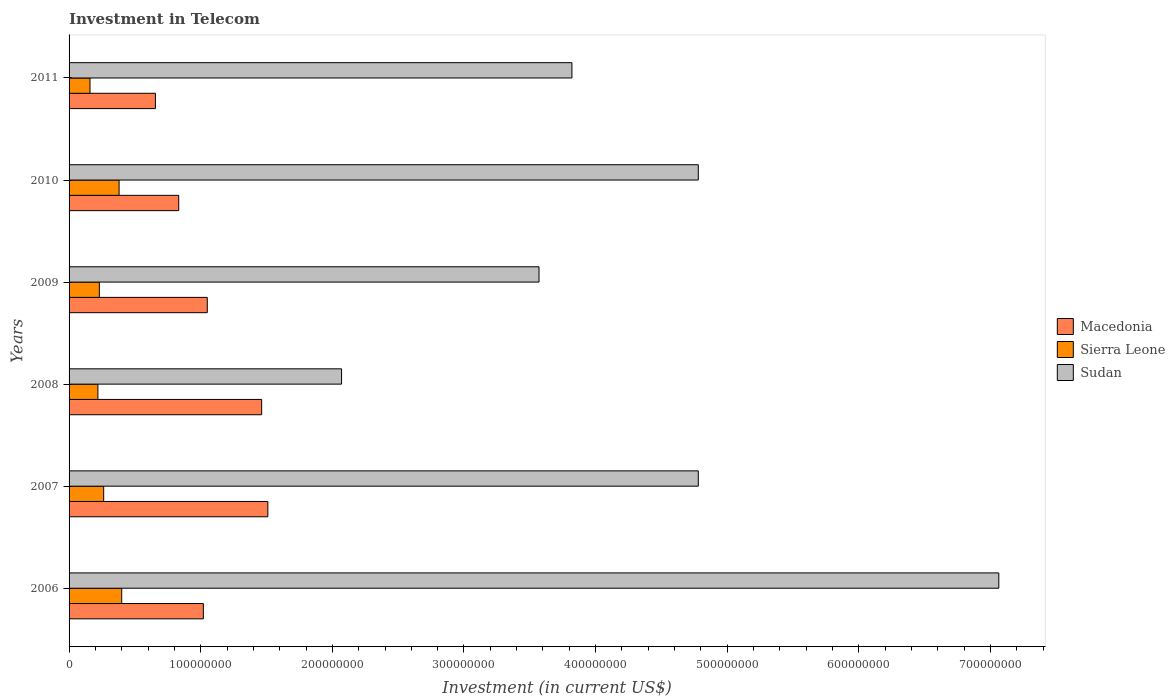How many different coloured bars are there?
Make the answer very short. 3. How many groups of bars are there?
Offer a very short reply. 6. How many bars are there on the 6th tick from the top?
Give a very brief answer. 3. What is the label of the 2nd group of bars from the top?
Provide a succinct answer. 2010. In how many cases, is the number of bars for a given year not equal to the number of legend labels?
Offer a terse response. 0. What is the amount invested in telecom in Sudan in 2009?
Keep it short and to the point. 3.57e+08. Across all years, what is the maximum amount invested in telecom in Sudan?
Make the answer very short. 7.06e+08. Across all years, what is the minimum amount invested in telecom in Macedonia?
Your response must be concise. 6.56e+07. What is the total amount invested in telecom in Macedonia in the graph?
Your answer should be compact. 6.53e+08. What is the difference between the amount invested in telecom in Sierra Leone in 2008 and that in 2010?
Offer a very short reply. -1.61e+07. What is the difference between the amount invested in telecom in Sierra Leone in 2010 and the amount invested in telecom in Sudan in 2011?
Keep it short and to the point. -3.44e+08. What is the average amount invested in telecom in Macedonia per year?
Your answer should be very brief. 1.09e+08. In the year 2008, what is the difference between the amount invested in telecom in Sierra Leone and amount invested in telecom in Sudan?
Make the answer very short. -1.85e+08. What is the ratio of the amount invested in telecom in Sierra Leone in 2007 to that in 2011?
Provide a succinct answer. 1.65. Is the amount invested in telecom in Sierra Leone in 2006 less than that in 2010?
Provide a short and direct response. No. Is the difference between the amount invested in telecom in Sierra Leone in 2009 and 2010 greater than the difference between the amount invested in telecom in Sudan in 2009 and 2010?
Offer a terse response. Yes. What is the difference between the highest and the lowest amount invested in telecom in Macedonia?
Keep it short and to the point. 8.54e+07. In how many years, is the amount invested in telecom in Sierra Leone greater than the average amount invested in telecom in Sierra Leone taken over all years?
Give a very brief answer. 2. Is the sum of the amount invested in telecom in Sudan in 2008 and 2010 greater than the maximum amount invested in telecom in Sierra Leone across all years?
Provide a short and direct response. Yes. What does the 2nd bar from the top in 2007 represents?
Provide a succinct answer. Sierra Leone. What does the 3rd bar from the bottom in 2007 represents?
Your answer should be very brief. Sudan. Is it the case that in every year, the sum of the amount invested in telecom in Sierra Leone and amount invested in telecom in Sudan is greater than the amount invested in telecom in Macedonia?
Your response must be concise. Yes. Are all the bars in the graph horizontal?
Your answer should be very brief. Yes. Does the graph contain grids?
Your answer should be compact. No. Where does the legend appear in the graph?
Offer a very short reply. Center right. What is the title of the graph?
Offer a very short reply. Investment in Telecom. Does "United States" appear as one of the legend labels in the graph?
Provide a short and direct response. No. What is the label or title of the X-axis?
Provide a short and direct response. Investment (in current US$). What is the label or title of the Y-axis?
Keep it short and to the point. Years. What is the Investment (in current US$) in Macedonia in 2006?
Your response must be concise. 1.02e+08. What is the Investment (in current US$) in Sierra Leone in 2006?
Make the answer very short. 4.00e+07. What is the Investment (in current US$) in Sudan in 2006?
Provide a succinct answer. 7.06e+08. What is the Investment (in current US$) of Macedonia in 2007?
Offer a terse response. 1.51e+08. What is the Investment (in current US$) in Sierra Leone in 2007?
Provide a succinct answer. 2.63e+07. What is the Investment (in current US$) of Sudan in 2007?
Give a very brief answer. 4.78e+08. What is the Investment (in current US$) of Macedonia in 2008?
Your answer should be very brief. 1.46e+08. What is the Investment (in current US$) of Sierra Leone in 2008?
Make the answer very short. 2.19e+07. What is the Investment (in current US$) in Sudan in 2008?
Give a very brief answer. 2.07e+08. What is the Investment (in current US$) of Macedonia in 2009?
Provide a succinct answer. 1.05e+08. What is the Investment (in current US$) of Sierra Leone in 2009?
Offer a very short reply. 2.30e+07. What is the Investment (in current US$) of Sudan in 2009?
Ensure brevity in your answer.  3.57e+08. What is the Investment (in current US$) in Macedonia in 2010?
Give a very brief answer. 8.33e+07. What is the Investment (in current US$) in Sierra Leone in 2010?
Give a very brief answer. 3.80e+07. What is the Investment (in current US$) of Sudan in 2010?
Provide a succinct answer. 4.78e+08. What is the Investment (in current US$) in Macedonia in 2011?
Make the answer very short. 6.56e+07. What is the Investment (in current US$) of Sierra Leone in 2011?
Give a very brief answer. 1.59e+07. What is the Investment (in current US$) of Sudan in 2011?
Give a very brief answer. 3.82e+08. Across all years, what is the maximum Investment (in current US$) in Macedonia?
Offer a very short reply. 1.51e+08. Across all years, what is the maximum Investment (in current US$) of Sierra Leone?
Ensure brevity in your answer.  4.00e+07. Across all years, what is the maximum Investment (in current US$) of Sudan?
Give a very brief answer. 7.06e+08. Across all years, what is the minimum Investment (in current US$) of Macedonia?
Keep it short and to the point. 6.56e+07. Across all years, what is the minimum Investment (in current US$) of Sierra Leone?
Give a very brief answer. 1.59e+07. Across all years, what is the minimum Investment (in current US$) in Sudan?
Make the answer very short. 2.07e+08. What is the total Investment (in current US$) of Macedonia in the graph?
Make the answer very short. 6.53e+08. What is the total Investment (in current US$) of Sierra Leone in the graph?
Give a very brief answer. 1.65e+08. What is the total Investment (in current US$) of Sudan in the graph?
Offer a very short reply. 2.61e+09. What is the difference between the Investment (in current US$) of Macedonia in 2006 and that in 2007?
Your answer should be very brief. -4.90e+07. What is the difference between the Investment (in current US$) in Sierra Leone in 2006 and that in 2007?
Provide a short and direct response. 1.37e+07. What is the difference between the Investment (in current US$) of Sudan in 2006 and that in 2007?
Give a very brief answer. 2.28e+08. What is the difference between the Investment (in current US$) of Macedonia in 2006 and that in 2008?
Make the answer very short. -4.43e+07. What is the difference between the Investment (in current US$) of Sierra Leone in 2006 and that in 2008?
Your answer should be very brief. 1.81e+07. What is the difference between the Investment (in current US$) of Sudan in 2006 and that in 2008?
Provide a short and direct response. 4.99e+08. What is the difference between the Investment (in current US$) in Macedonia in 2006 and that in 2009?
Give a very brief answer. -3.00e+06. What is the difference between the Investment (in current US$) of Sierra Leone in 2006 and that in 2009?
Provide a succinct answer. 1.70e+07. What is the difference between the Investment (in current US$) in Sudan in 2006 and that in 2009?
Offer a terse response. 3.49e+08. What is the difference between the Investment (in current US$) of Macedonia in 2006 and that in 2010?
Keep it short and to the point. 1.87e+07. What is the difference between the Investment (in current US$) of Sudan in 2006 and that in 2010?
Ensure brevity in your answer.  2.28e+08. What is the difference between the Investment (in current US$) in Macedonia in 2006 and that in 2011?
Offer a very short reply. 3.64e+07. What is the difference between the Investment (in current US$) in Sierra Leone in 2006 and that in 2011?
Provide a succinct answer. 2.41e+07. What is the difference between the Investment (in current US$) of Sudan in 2006 and that in 2011?
Your answer should be very brief. 3.24e+08. What is the difference between the Investment (in current US$) of Macedonia in 2007 and that in 2008?
Provide a short and direct response. 4.70e+06. What is the difference between the Investment (in current US$) in Sierra Leone in 2007 and that in 2008?
Provide a succinct answer. 4.40e+06. What is the difference between the Investment (in current US$) in Sudan in 2007 and that in 2008?
Ensure brevity in your answer.  2.71e+08. What is the difference between the Investment (in current US$) of Macedonia in 2007 and that in 2009?
Offer a terse response. 4.60e+07. What is the difference between the Investment (in current US$) of Sierra Leone in 2007 and that in 2009?
Offer a terse response. 3.30e+06. What is the difference between the Investment (in current US$) of Sudan in 2007 and that in 2009?
Your answer should be compact. 1.21e+08. What is the difference between the Investment (in current US$) in Macedonia in 2007 and that in 2010?
Keep it short and to the point. 6.77e+07. What is the difference between the Investment (in current US$) of Sierra Leone in 2007 and that in 2010?
Provide a succinct answer. -1.17e+07. What is the difference between the Investment (in current US$) in Sudan in 2007 and that in 2010?
Ensure brevity in your answer.  0. What is the difference between the Investment (in current US$) of Macedonia in 2007 and that in 2011?
Your answer should be very brief. 8.54e+07. What is the difference between the Investment (in current US$) in Sierra Leone in 2007 and that in 2011?
Your answer should be very brief. 1.04e+07. What is the difference between the Investment (in current US$) of Sudan in 2007 and that in 2011?
Ensure brevity in your answer.  9.60e+07. What is the difference between the Investment (in current US$) of Macedonia in 2008 and that in 2009?
Provide a short and direct response. 4.13e+07. What is the difference between the Investment (in current US$) of Sierra Leone in 2008 and that in 2009?
Provide a succinct answer. -1.10e+06. What is the difference between the Investment (in current US$) in Sudan in 2008 and that in 2009?
Your answer should be very brief. -1.50e+08. What is the difference between the Investment (in current US$) of Macedonia in 2008 and that in 2010?
Give a very brief answer. 6.30e+07. What is the difference between the Investment (in current US$) in Sierra Leone in 2008 and that in 2010?
Ensure brevity in your answer.  -1.61e+07. What is the difference between the Investment (in current US$) of Sudan in 2008 and that in 2010?
Make the answer very short. -2.71e+08. What is the difference between the Investment (in current US$) of Macedonia in 2008 and that in 2011?
Your response must be concise. 8.07e+07. What is the difference between the Investment (in current US$) of Sierra Leone in 2008 and that in 2011?
Ensure brevity in your answer.  6.00e+06. What is the difference between the Investment (in current US$) in Sudan in 2008 and that in 2011?
Offer a very short reply. -1.75e+08. What is the difference between the Investment (in current US$) of Macedonia in 2009 and that in 2010?
Keep it short and to the point. 2.17e+07. What is the difference between the Investment (in current US$) in Sierra Leone in 2009 and that in 2010?
Offer a terse response. -1.50e+07. What is the difference between the Investment (in current US$) of Sudan in 2009 and that in 2010?
Ensure brevity in your answer.  -1.21e+08. What is the difference between the Investment (in current US$) in Macedonia in 2009 and that in 2011?
Give a very brief answer. 3.94e+07. What is the difference between the Investment (in current US$) of Sierra Leone in 2009 and that in 2011?
Make the answer very short. 7.10e+06. What is the difference between the Investment (in current US$) of Sudan in 2009 and that in 2011?
Offer a terse response. -2.50e+07. What is the difference between the Investment (in current US$) of Macedonia in 2010 and that in 2011?
Your answer should be compact. 1.77e+07. What is the difference between the Investment (in current US$) of Sierra Leone in 2010 and that in 2011?
Your answer should be very brief. 2.21e+07. What is the difference between the Investment (in current US$) of Sudan in 2010 and that in 2011?
Keep it short and to the point. 9.60e+07. What is the difference between the Investment (in current US$) of Macedonia in 2006 and the Investment (in current US$) of Sierra Leone in 2007?
Keep it short and to the point. 7.57e+07. What is the difference between the Investment (in current US$) in Macedonia in 2006 and the Investment (in current US$) in Sudan in 2007?
Your answer should be compact. -3.76e+08. What is the difference between the Investment (in current US$) of Sierra Leone in 2006 and the Investment (in current US$) of Sudan in 2007?
Offer a terse response. -4.38e+08. What is the difference between the Investment (in current US$) in Macedonia in 2006 and the Investment (in current US$) in Sierra Leone in 2008?
Give a very brief answer. 8.01e+07. What is the difference between the Investment (in current US$) of Macedonia in 2006 and the Investment (in current US$) of Sudan in 2008?
Your response must be concise. -1.05e+08. What is the difference between the Investment (in current US$) in Sierra Leone in 2006 and the Investment (in current US$) in Sudan in 2008?
Make the answer very short. -1.67e+08. What is the difference between the Investment (in current US$) in Macedonia in 2006 and the Investment (in current US$) in Sierra Leone in 2009?
Provide a short and direct response. 7.90e+07. What is the difference between the Investment (in current US$) in Macedonia in 2006 and the Investment (in current US$) in Sudan in 2009?
Your response must be concise. -2.55e+08. What is the difference between the Investment (in current US$) of Sierra Leone in 2006 and the Investment (in current US$) of Sudan in 2009?
Ensure brevity in your answer.  -3.17e+08. What is the difference between the Investment (in current US$) of Macedonia in 2006 and the Investment (in current US$) of Sierra Leone in 2010?
Make the answer very short. 6.40e+07. What is the difference between the Investment (in current US$) in Macedonia in 2006 and the Investment (in current US$) in Sudan in 2010?
Keep it short and to the point. -3.76e+08. What is the difference between the Investment (in current US$) of Sierra Leone in 2006 and the Investment (in current US$) of Sudan in 2010?
Give a very brief answer. -4.38e+08. What is the difference between the Investment (in current US$) of Macedonia in 2006 and the Investment (in current US$) of Sierra Leone in 2011?
Keep it short and to the point. 8.61e+07. What is the difference between the Investment (in current US$) in Macedonia in 2006 and the Investment (in current US$) in Sudan in 2011?
Your answer should be compact. -2.80e+08. What is the difference between the Investment (in current US$) of Sierra Leone in 2006 and the Investment (in current US$) of Sudan in 2011?
Provide a short and direct response. -3.42e+08. What is the difference between the Investment (in current US$) of Macedonia in 2007 and the Investment (in current US$) of Sierra Leone in 2008?
Your answer should be compact. 1.29e+08. What is the difference between the Investment (in current US$) of Macedonia in 2007 and the Investment (in current US$) of Sudan in 2008?
Make the answer very short. -5.60e+07. What is the difference between the Investment (in current US$) in Sierra Leone in 2007 and the Investment (in current US$) in Sudan in 2008?
Provide a succinct answer. -1.81e+08. What is the difference between the Investment (in current US$) in Macedonia in 2007 and the Investment (in current US$) in Sierra Leone in 2009?
Your answer should be very brief. 1.28e+08. What is the difference between the Investment (in current US$) in Macedonia in 2007 and the Investment (in current US$) in Sudan in 2009?
Give a very brief answer. -2.06e+08. What is the difference between the Investment (in current US$) of Sierra Leone in 2007 and the Investment (in current US$) of Sudan in 2009?
Your response must be concise. -3.31e+08. What is the difference between the Investment (in current US$) of Macedonia in 2007 and the Investment (in current US$) of Sierra Leone in 2010?
Offer a terse response. 1.13e+08. What is the difference between the Investment (in current US$) in Macedonia in 2007 and the Investment (in current US$) in Sudan in 2010?
Ensure brevity in your answer.  -3.27e+08. What is the difference between the Investment (in current US$) in Sierra Leone in 2007 and the Investment (in current US$) in Sudan in 2010?
Ensure brevity in your answer.  -4.52e+08. What is the difference between the Investment (in current US$) in Macedonia in 2007 and the Investment (in current US$) in Sierra Leone in 2011?
Your response must be concise. 1.35e+08. What is the difference between the Investment (in current US$) in Macedonia in 2007 and the Investment (in current US$) in Sudan in 2011?
Offer a terse response. -2.31e+08. What is the difference between the Investment (in current US$) of Sierra Leone in 2007 and the Investment (in current US$) of Sudan in 2011?
Your answer should be compact. -3.56e+08. What is the difference between the Investment (in current US$) of Macedonia in 2008 and the Investment (in current US$) of Sierra Leone in 2009?
Offer a terse response. 1.23e+08. What is the difference between the Investment (in current US$) in Macedonia in 2008 and the Investment (in current US$) in Sudan in 2009?
Your answer should be very brief. -2.11e+08. What is the difference between the Investment (in current US$) of Sierra Leone in 2008 and the Investment (in current US$) of Sudan in 2009?
Provide a short and direct response. -3.35e+08. What is the difference between the Investment (in current US$) of Macedonia in 2008 and the Investment (in current US$) of Sierra Leone in 2010?
Ensure brevity in your answer.  1.08e+08. What is the difference between the Investment (in current US$) in Macedonia in 2008 and the Investment (in current US$) in Sudan in 2010?
Offer a terse response. -3.32e+08. What is the difference between the Investment (in current US$) of Sierra Leone in 2008 and the Investment (in current US$) of Sudan in 2010?
Make the answer very short. -4.56e+08. What is the difference between the Investment (in current US$) of Macedonia in 2008 and the Investment (in current US$) of Sierra Leone in 2011?
Your answer should be compact. 1.30e+08. What is the difference between the Investment (in current US$) of Macedonia in 2008 and the Investment (in current US$) of Sudan in 2011?
Keep it short and to the point. -2.36e+08. What is the difference between the Investment (in current US$) in Sierra Leone in 2008 and the Investment (in current US$) in Sudan in 2011?
Keep it short and to the point. -3.60e+08. What is the difference between the Investment (in current US$) of Macedonia in 2009 and the Investment (in current US$) of Sierra Leone in 2010?
Offer a terse response. 6.70e+07. What is the difference between the Investment (in current US$) in Macedonia in 2009 and the Investment (in current US$) in Sudan in 2010?
Provide a succinct answer. -3.73e+08. What is the difference between the Investment (in current US$) in Sierra Leone in 2009 and the Investment (in current US$) in Sudan in 2010?
Offer a very short reply. -4.55e+08. What is the difference between the Investment (in current US$) of Macedonia in 2009 and the Investment (in current US$) of Sierra Leone in 2011?
Provide a short and direct response. 8.91e+07. What is the difference between the Investment (in current US$) in Macedonia in 2009 and the Investment (in current US$) in Sudan in 2011?
Offer a terse response. -2.77e+08. What is the difference between the Investment (in current US$) of Sierra Leone in 2009 and the Investment (in current US$) of Sudan in 2011?
Make the answer very short. -3.59e+08. What is the difference between the Investment (in current US$) in Macedonia in 2010 and the Investment (in current US$) in Sierra Leone in 2011?
Offer a very short reply. 6.74e+07. What is the difference between the Investment (in current US$) of Macedonia in 2010 and the Investment (in current US$) of Sudan in 2011?
Your answer should be compact. -2.99e+08. What is the difference between the Investment (in current US$) in Sierra Leone in 2010 and the Investment (in current US$) in Sudan in 2011?
Your answer should be very brief. -3.44e+08. What is the average Investment (in current US$) in Macedonia per year?
Ensure brevity in your answer.  1.09e+08. What is the average Investment (in current US$) of Sierra Leone per year?
Make the answer very short. 2.75e+07. What is the average Investment (in current US$) of Sudan per year?
Offer a very short reply. 4.35e+08. In the year 2006, what is the difference between the Investment (in current US$) in Macedonia and Investment (in current US$) in Sierra Leone?
Your answer should be very brief. 6.20e+07. In the year 2006, what is the difference between the Investment (in current US$) of Macedonia and Investment (in current US$) of Sudan?
Your answer should be very brief. -6.04e+08. In the year 2006, what is the difference between the Investment (in current US$) in Sierra Leone and Investment (in current US$) in Sudan?
Your answer should be very brief. -6.66e+08. In the year 2007, what is the difference between the Investment (in current US$) of Macedonia and Investment (in current US$) of Sierra Leone?
Your answer should be compact. 1.25e+08. In the year 2007, what is the difference between the Investment (in current US$) of Macedonia and Investment (in current US$) of Sudan?
Give a very brief answer. -3.27e+08. In the year 2007, what is the difference between the Investment (in current US$) of Sierra Leone and Investment (in current US$) of Sudan?
Give a very brief answer. -4.52e+08. In the year 2008, what is the difference between the Investment (in current US$) of Macedonia and Investment (in current US$) of Sierra Leone?
Your answer should be very brief. 1.24e+08. In the year 2008, what is the difference between the Investment (in current US$) of Macedonia and Investment (in current US$) of Sudan?
Offer a terse response. -6.07e+07. In the year 2008, what is the difference between the Investment (in current US$) of Sierra Leone and Investment (in current US$) of Sudan?
Offer a terse response. -1.85e+08. In the year 2009, what is the difference between the Investment (in current US$) of Macedonia and Investment (in current US$) of Sierra Leone?
Make the answer very short. 8.20e+07. In the year 2009, what is the difference between the Investment (in current US$) in Macedonia and Investment (in current US$) in Sudan?
Keep it short and to the point. -2.52e+08. In the year 2009, what is the difference between the Investment (in current US$) in Sierra Leone and Investment (in current US$) in Sudan?
Provide a succinct answer. -3.34e+08. In the year 2010, what is the difference between the Investment (in current US$) in Macedonia and Investment (in current US$) in Sierra Leone?
Provide a short and direct response. 4.53e+07. In the year 2010, what is the difference between the Investment (in current US$) in Macedonia and Investment (in current US$) in Sudan?
Offer a terse response. -3.95e+08. In the year 2010, what is the difference between the Investment (in current US$) in Sierra Leone and Investment (in current US$) in Sudan?
Your response must be concise. -4.40e+08. In the year 2011, what is the difference between the Investment (in current US$) in Macedonia and Investment (in current US$) in Sierra Leone?
Your answer should be very brief. 4.97e+07. In the year 2011, what is the difference between the Investment (in current US$) of Macedonia and Investment (in current US$) of Sudan?
Your answer should be very brief. -3.16e+08. In the year 2011, what is the difference between the Investment (in current US$) of Sierra Leone and Investment (in current US$) of Sudan?
Ensure brevity in your answer.  -3.66e+08. What is the ratio of the Investment (in current US$) of Macedonia in 2006 to that in 2007?
Keep it short and to the point. 0.68. What is the ratio of the Investment (in current US$) in Sierra Leone in 2006 to that in 2007?
Your response must be concise. 1.52. What is the ratio of the Investment (in current US$) of Sudan in 2006 to that in 2007?
Provide a short and direct response. 1.48. What is the ratio of the Investment (in current US$) in Macedonia in 2006 to that in 2008?
Provide a short and direct response. 0.7. What is the ratio of the Investment (in current US$) in Sierra Leone in 2006 to that in 2008?
Give a very brief answer. 1.83. What is the ratio of the Investment (in current US$) in Sudan in 2006 to that in 2008?
Provide a succinct answer. 3.41. What is the ratio of the Investment (in current US$) of Macedonia in 2006 to that in 2009?
Provide a succinct answer. 0.97. What is the ratio of the Investment (in current US$) in Sierra Leone in 2006 to that in 2009?
Your answer should be very brief. 1.74. What is the ratio of the Investment (in current US$) in Sudan in 2006 to that in 2009?
Ensure brevity in your answer.  1.98. What is the ratio of the Investment (in current US$) in Macedonia in 2006 to that in 2010?
Give a very brief answer. 1.22. What is the ratio of the Investment (in current US$) in Sierra Leone in 2006 to that in 2010?
Keep it short and to the point. 1.05. What is the ratio of the Investment (in current US$) in Sudan in 2006 to that in 2010?
Keep it short and to the point. 1.48. What is the ratio of the Investment (in current US$) in Macedonia in 2006 to that in 2011?
Offer a terse response. 1.55. What is the ratio of the Investment (in current US$) of Sierra Leone in 2006 to that in 2011?
Your answer should be compact. 2.52. What is the ratio of the Investment (in current US$) in Sudan in 2006 to that in 2011?
Offer a terse response. 1.85. What is the ratio of the Investment (in current US$) in Macedonia in 2007 to that in 2008?
Make the answer very short. 1.03. What is the ratio of the Investment (in current US$) in Sierra Leone in 2007 to that in 2008?
Ensure brevity in your answer.  1.2. What is the ratio of the Investment (in current US$) of Sudan in 2007 to that in 2008?
Your response must be concise. 2.31. What is the ratio of the Investment (in current US$) in Macedonia in 2007 to that in 2009?
Your answer should be very brief. 1.44. What is the ratio of the Investment (in current US$) in Sierra Leone in 2007 to that in 2009?
Offer a very short reply. 1.14. What is the ratio of the Investment (in current US$) in Sudan in 2007 to that in 2009?
Provide a short and direct response. 1.34. What is the ratio of the Investment (in current US$) of Macedonia in 2007 to that in 2010?
Ensure brevity in your answer.  1.81. What is the ratio of the Investment (in current US$) in Sierra Leone in 2007 to that in 2010?
Your answer should be compact. 0.69. What is the ratio of the Investment (in current US$) of Macedonia in 2007 to that in 2011?
Provide a succinct answer. 2.3. What is the ratio of the Investment (in current US$) of Sierra Leone in 2007 to that in 2011?
Make the answer very short. 1.65. What is the ratio of the Investment (in current US$) in Sudan in 2007 to that in 2011?
Provide a short and direct response. 1.25. What is the ratio of the Investment (in current US$) of Macedonia in 2008 to that in 2009?
Your answer should be very brief. 1.39. What is the ratio of the Investment (in current US$) of Sierra Leone in 2008 to that in 2009?
Your response must be concise. 0.95. What is the ratio of the Investment (in current US$) of Sudan in 2008 to that in 2009?
Your response must be concise. 0.58. What is the ratio of the Investment (in current US$) in Macedonia in 2008 to that in 2010?
Offer a terse response. 1.76. What is the ratio of the Investment (in current US$) of Sierra Leone in 2008 to that in 2010?
Your response must be concise. 0.58. What is the ratio of the Investment (in current US$) in Sudan in 2008 to that in 2010?
Offer a terse response. 0.43. What is the ratio of the Investment (in current US$) in Macedonia in 2008 to that in 2011?
Provide a short and direct response. 2.23. What is the ratio of the Investment (in current US$) in Sierra Leone in 2008 to that in 2011?
Your response must be concise. 1.38. What is the ratio of the Investment (in current US$) in Sudan in 2008 to that in 2011?
Provide a succinct answer. 0.54. What is the ratio of the Investment (in current US$) in Macedonia in 2009 to that in 2010?
Ensure brevity in your answer.  1.26. What is the ratio of the Investment (in current US$) of Sierra Leone in 2009 to that in 2010?
Keep it short and to the point. 0.61. What is the ratio of the Investment (in current US$) in Sudan in 2009 to that in 2010?
Ensure brevity in your answer.  0.75. What is the ratio of the Investment (in current US$) in Macedonia in 2009 to that in 2011?
Keep it short and to the point. 1.6. What is the ratio of the Investment (in current US$) of Sierra Leone in 2009 to that in 2011?
Give a very brief answer. 1.45. What is the ratio of the Investment (in current US$) in Sudan in 2009 to that in 2011?
Provide a short and direct response. 0.93. What is the ratio of the Investment (in current US$) of Macedonia in 2010 to that in 2011?
Your response must be concise. 1.27. What is the ratio of the Investment (in current US$) in Sierra Leone in 2010 to that in 2011?
Offer a terse response. 2.39. What is the ratio of the Investment (in current US$) of Sudan in 2010 to that in 2011?
Your response must be concise. 1.25. What is the difference between the highest and the second highest Investment (in current US$) of Macedonia?
Offer a terse response. 4.70e+06. What is the difference between the highest and the second highest Investment (in current US$) of Sierra Leone?
Your answer should be compact. 2.00e+06. What is the difference between the highest and the second highest Investment (in current US$) of Sudan?
Make the answer very short. 2.28e+08. What is the difference between the highest and the lowest Investment (in current US$) in Macedonia?
Your answer should be compact. 8.54e+07. What is the difference between the highest and the lowest Investment (in current US$) of Sierra Leone?
Your response must be concise. 2.41e+07. What is the difference between the highest and the lowest Investment (in current US$) in Sudan?
Provide a short and direct response. 4.99e+08. 